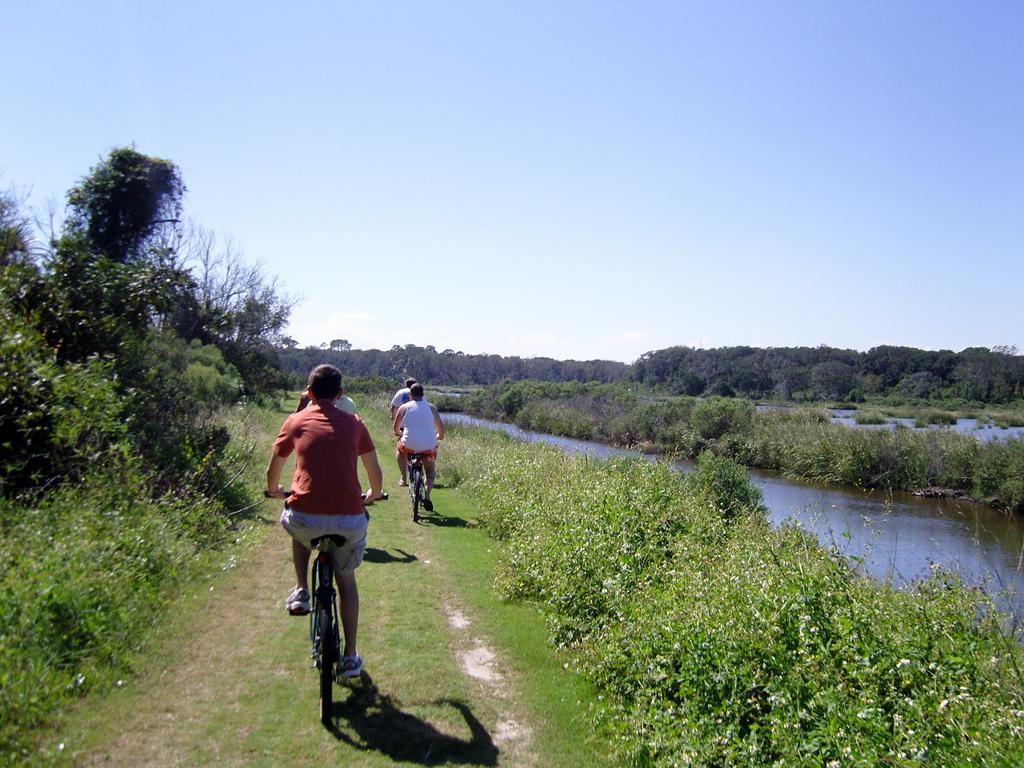How would you summarize this image in a sentence or two? At the top of picture we can see a clear blue sky and it seems like a sunny day. On the background we can see trees. these are the plants. Here we can see a road with fresh green grass. We can see few persons riding a bicycle here. This is a lake. 